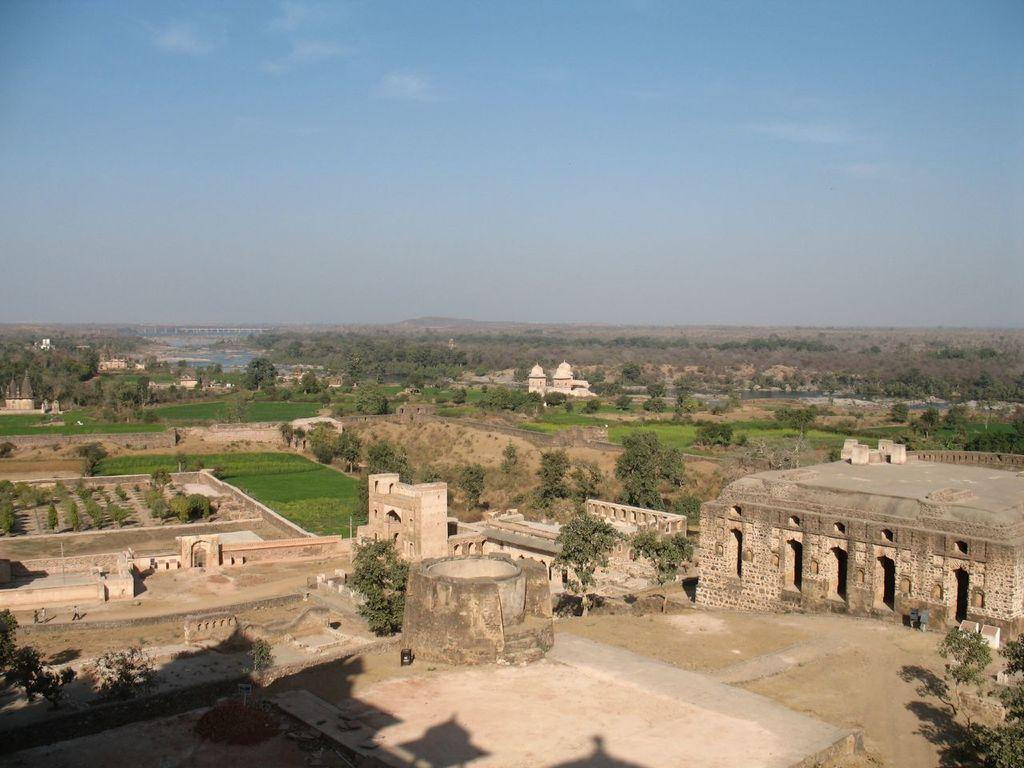What structures can be seen in the image? There are different types of forts in the image. What type of terrain is visible in the image? There is grass visible in the image. What other natural elements can be seen in the image? There are many trees in the image. What is visible in the background of the image? The sky is visible in the background of the image. How many jellyfish can be seen swimming in the image? There are no jellyfish present in the image; it features forts, grass, trees, and the sky. 